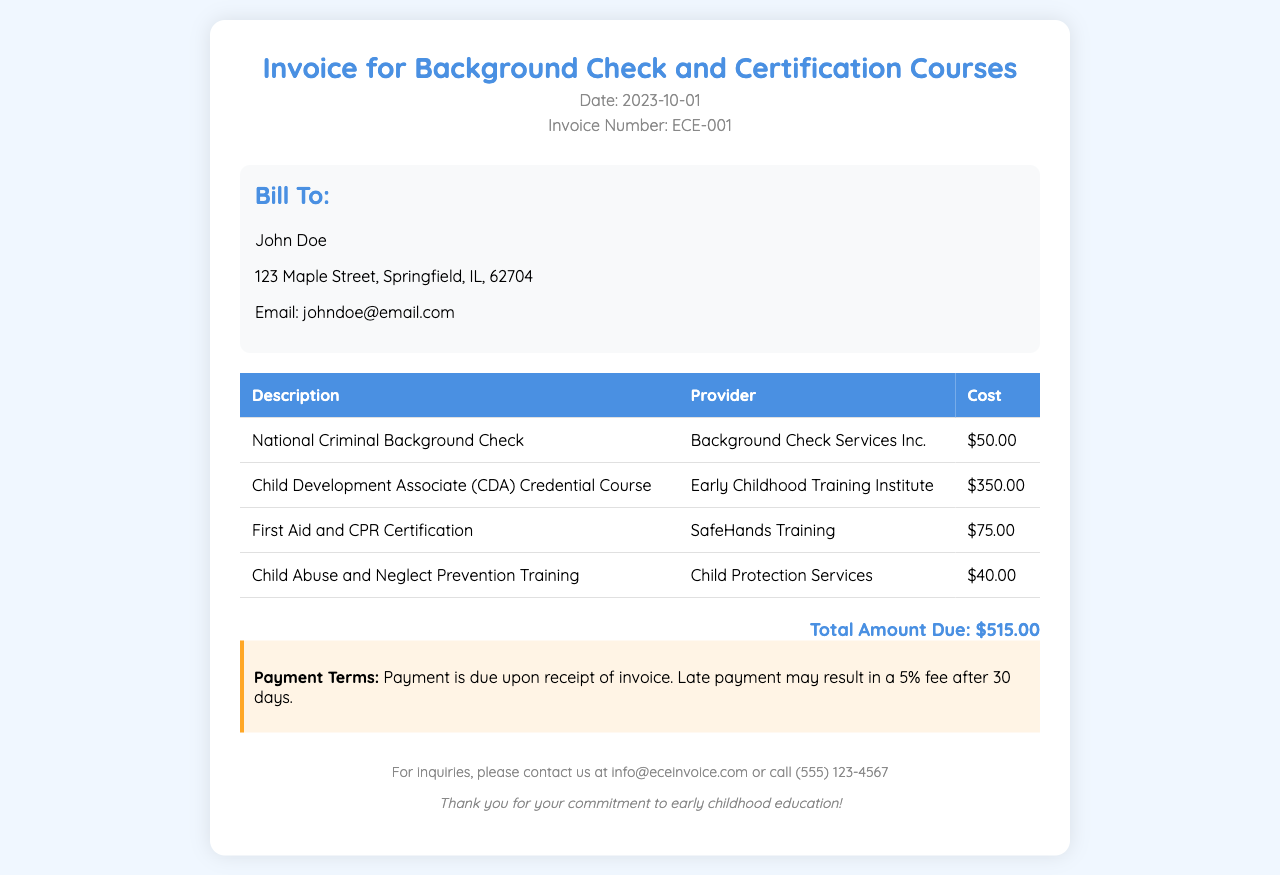what is the invoice date? The invoice date is clearly stated in the header section of the document.
Answer: 2023-10-01 who is the service provider for the First Aid and CPR Certification? The provider's name can be found in the table listing services rendered.
Answer: SafeHands Training what is the cost of the Child Development Associate Credential Course? The cost is listed next to the course description in the invoice table.
Answer: $350.00 how much is the total amount due? The total amount due is summarized at the bottom of the invoice.
Answer: $515.00 what are the payment terms? The payment terms are specified in a separate section below the total amount due.
Answer: Payment is due upon receipt of invoice who is the invoice billed to? The billing information is provided in the "Bill To" section of the document.
Answer: John Doe what training is provided by Child Protection Services? The training title can be found in the description column of the invoice table.
Answer: Child Abuse and Neglect Prevention Training how many services are listed in the invoice? Counting the rows in the service table gives the number of services rendered on the invoice.
Answer: 4 